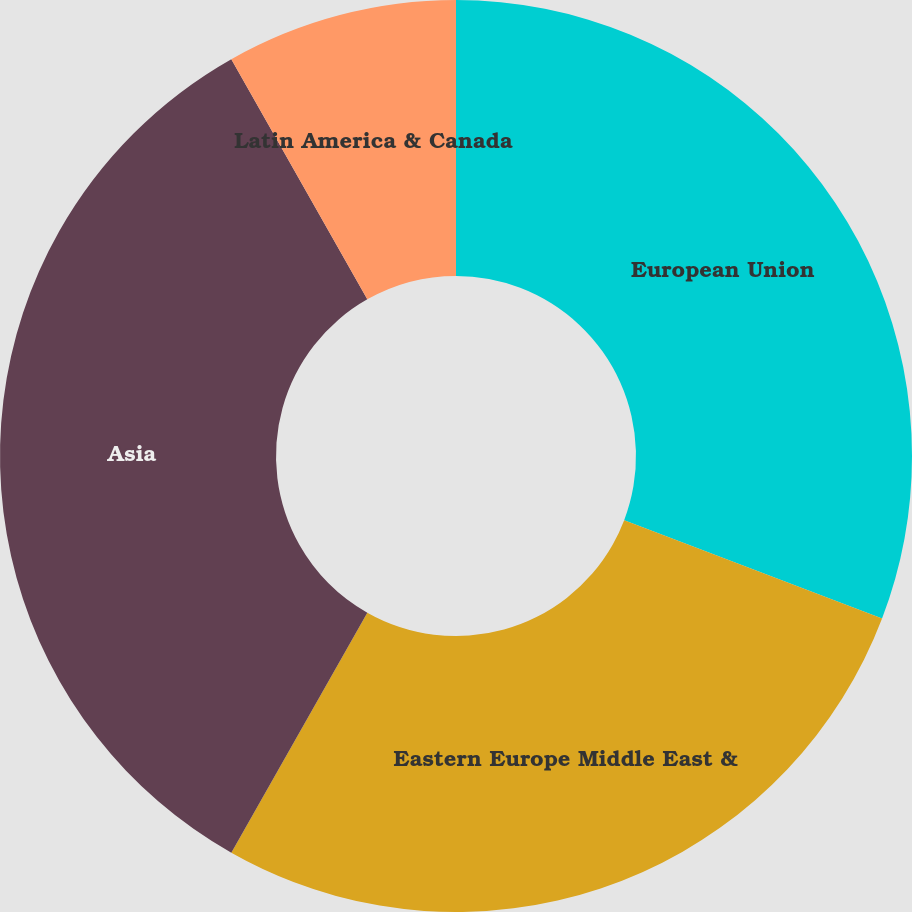Convert chart to OTSL. <chart><loc_0><loc_0><loc_500><loc_500><pie_chart><fcel>European Union<fcel>Eastern Europe Middle East &<fcel>Asia<fcel>Latin America & Canada<nl><fcel>30.8%<fcel>27.4%<fcel>33.6%<fcel>8.2%<nl></chart> 